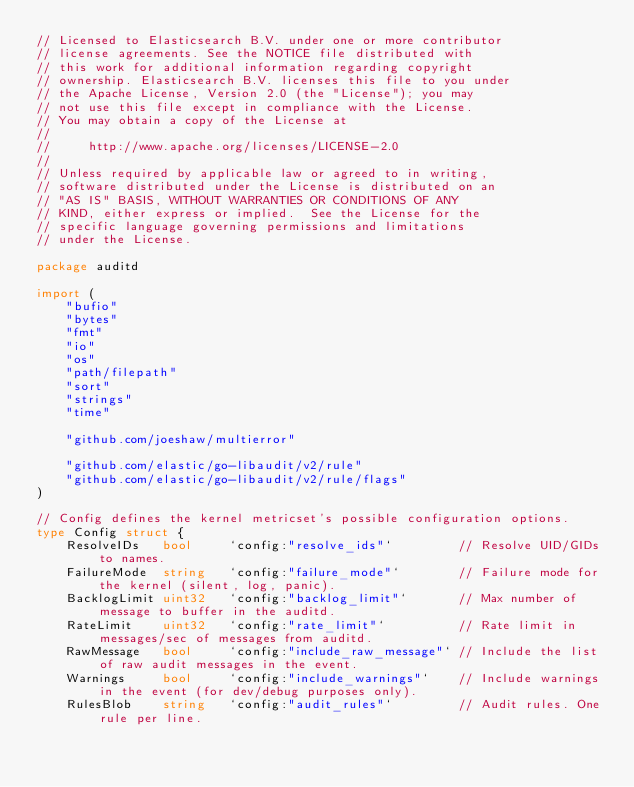Convert code to text. <code><loc_0><loc_0><loc_500><loc_500><_Go_>// Licensed to Elasticsearch B.V. under one or more contributor
// license agreements. See the NOTICE file distributed with
// this work for additional information regarding copyright
// ownership. Elasticsearch B.V. licenses this file to you under
// the Apache License, Version 2.0 (the "License"); you may
// not use this file except in compliance with the License.
// You may obtain a copy of the License at
//
//     http://www.apache.org/licenses/LICENSE-2.0
//
// Unless required by applicable law or agreed to in writing,
// software distributed under the License is distributed on an
// "AS IS" BASIS, WITHOUT WARRANTIES OR CONDITIONS OF ANY
// KIND, either express or implied.  See the License for the
// specific language governing permissions and limitations
// under the License.

package auditd

import (
	"bufio"
	"bytes"
	"fmt"
	"io"
	"os"
	"path/filepath"
	"sort"
	"strings"
	"time"

	"github.com/joeshaw/multierror"

	"github.com/elastic/go-libaudit/v2/rule"
	"github.com/elastic/go-libaudit/v2/rule/flags"
)

// Config defines the kernel metricset's possible configuration options.
type Config struct {
	ResolveIDs   bool     `config:"resolve_ids"`         // Resolve UID/GIDs to names.
	FailureMode  string   `config:"failure_mode"`        // Failure mode for the kernel (silent, log, panic).
	BacklogLimit uint32   `config:"backlog_limit"`       // Max number of message to buffer in the auditd.
	RateLimit    uint32   `config:"rate_limit"`          // Rate limit in messages/sec of messages from auditd.
	RawMessage   bool     `config:"include_raw_message"` // Include the list of raw audit messages in the event.
	Warnings     bool     `config:"include_warnings"`    // Include warnings in the event (for dev/debug purposes only).
	RulesBlob    string   `config:"audit_rules"`         // Audit rules. One rule per line.</code> 